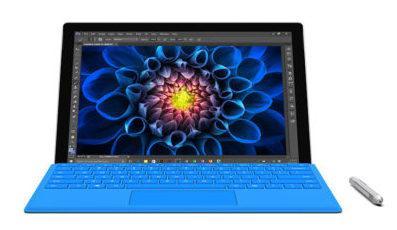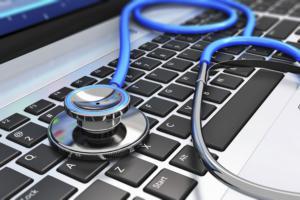The first image is the image on the left, the second image is the image on the right. For the images displayed, is the sentence "There are more than two laptops." factually correct? Answer yes or no. No. The first image is the image on the left, the second image is the image on the right. Assess this claim about the two images: "One image includes at least one laptop with its open screen showing a blue nature-themed picture, and the other image contains one computer keyboard.". Correct or not? Answer yes or no. Yes. 